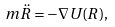Convert formula to latex. <formula><loc_0><loc_0><loc_500><loc_500>m \ddot { R } = - \nabla U ( R ) ,</formula> 